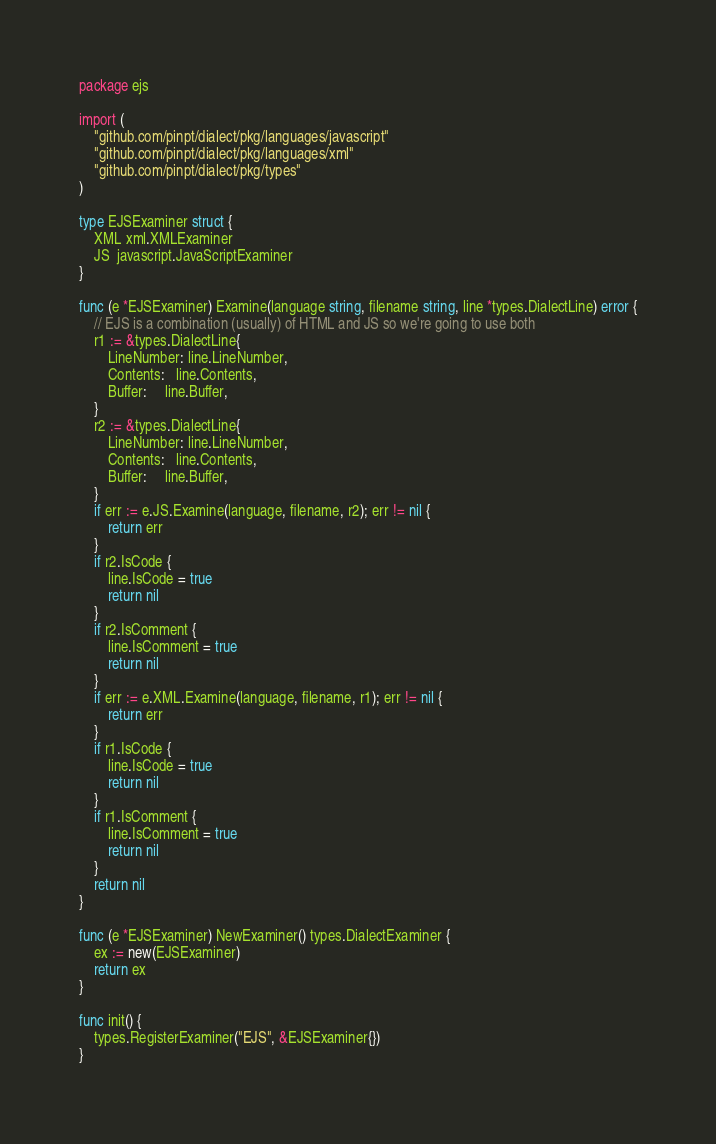<code> <loc_0><loc_0><loc_500><loc_500><_Go_>package ejs

import (
	"github.com/pinpt/dialect/pkg/languages/javascript"
	"github.com/pinpt/dialect/pkg/languages/xml"
	"github.com/pinpt/dialect/pkg/types"
)

type EJSExaminer struct {
	XML xml.XMLExaminer
	JS  javascript.JavaScriptExaminer
}

func (e *EJSExaminer) Examine(language string, filename string, line *types.DialectLine) error {
	// EJS is a combination (usually) of HTML and JS so we're going to use both
	r1 := &types.DialectLine{
		LineNumber: line.LineNumber,
		Contents:   line.Contents,
		Buffer:     line.Buffer,
	}
	r2 := &types.DialectLine{
		LineNumber: line.LineNumber,
		Contents:   line.Contents,
		Buffer:     line.Buffer,
	}
	if err := e.JS.Examine(language, filename, r2); err != nil {
		return err
	}
	if r2.IsCode {
		line.IsCode = true
		return nil
	}
	if r2.IsComment {
		line.IsComment = true
		return nil
	}
	if err := e.XML.Examine(language, filename, r1); err != nil {
		return err
	}
	if r1.IsCode {
		line.IsCode = true
		return nil
	}
	if r1.IsComment {
		line.IsComment = true
		return nil
	}
	return nil
}

func (e *EJSExaminer) NewExaminer() types.DialectExaminer {
	ex := new(EJSExaminer)
	return ex
}

func init() {
	types.RegisterExaminer("EJS", &EJSExaminer{})
}
</code> 